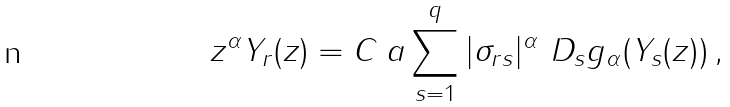<formula> <loc_0><loc_0><loc_500><loc_500>z ^ { \alpha } Y _ { r } ( z ) = C _ { \ } a \sum _ { s = 1 } ^ { q } | \sigma _ { r s } | ^ { \alpha } \ D _ { s } g _ { \alpha } ( Y _ { s } ( z ) ) \, ,</formula> 